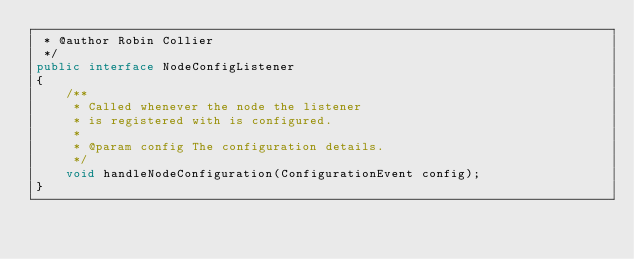Convert code to text. <code><loc_0><loc_0><loc_500><loc_500><_Java_> * @author Robin Collier
 */
public interface NodeConfigListener
{
    /**
     * Called whenever the node the listener
     * is registered with is configured.
     * 
     * @param config The configuration details.
     */
    void handleNodeConfiguration(ConfigurationEvent config);
}
</code> 